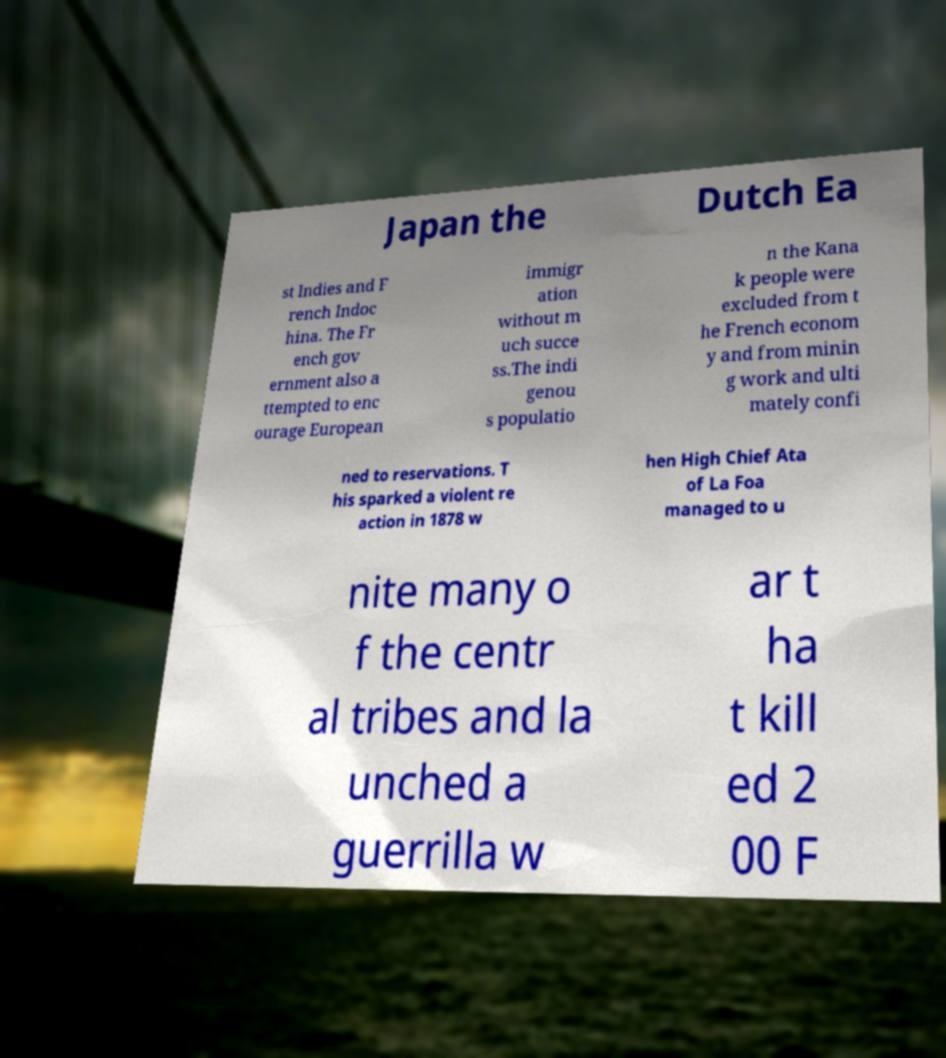Can you accurately transcribe the text from the provided image for me? Japan the Dutch Ea st Indies and F rench Indoc hina. The Fr ench gov ernment also a ttempted to enc ourage European immigr ation without m uch succe ss.The indi genou s populatio n the Kana k people were excluded from t he French econom y and from minin g work and ulti mately confi ned to reservations. T his sparked a violent re action in 1878 w hen High Chief Ata of La Foa managed to u nite many o f the centr al tribes and la unched a guerrilla w ar t ha t kill ed 2 00 F 